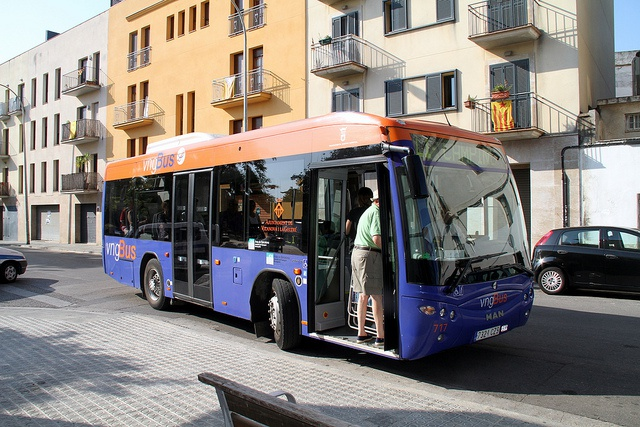Describe the objects in this image and their specific colors. I can see bus in white, black, gray, darkgray, and lightgray tones, car in white, black, gray, navy, and blue tones, people in white, beige, black, and gray tones, bench in white, black, gray, and darkgray tones, and car in white, black, gray, and navy tones in this image. 